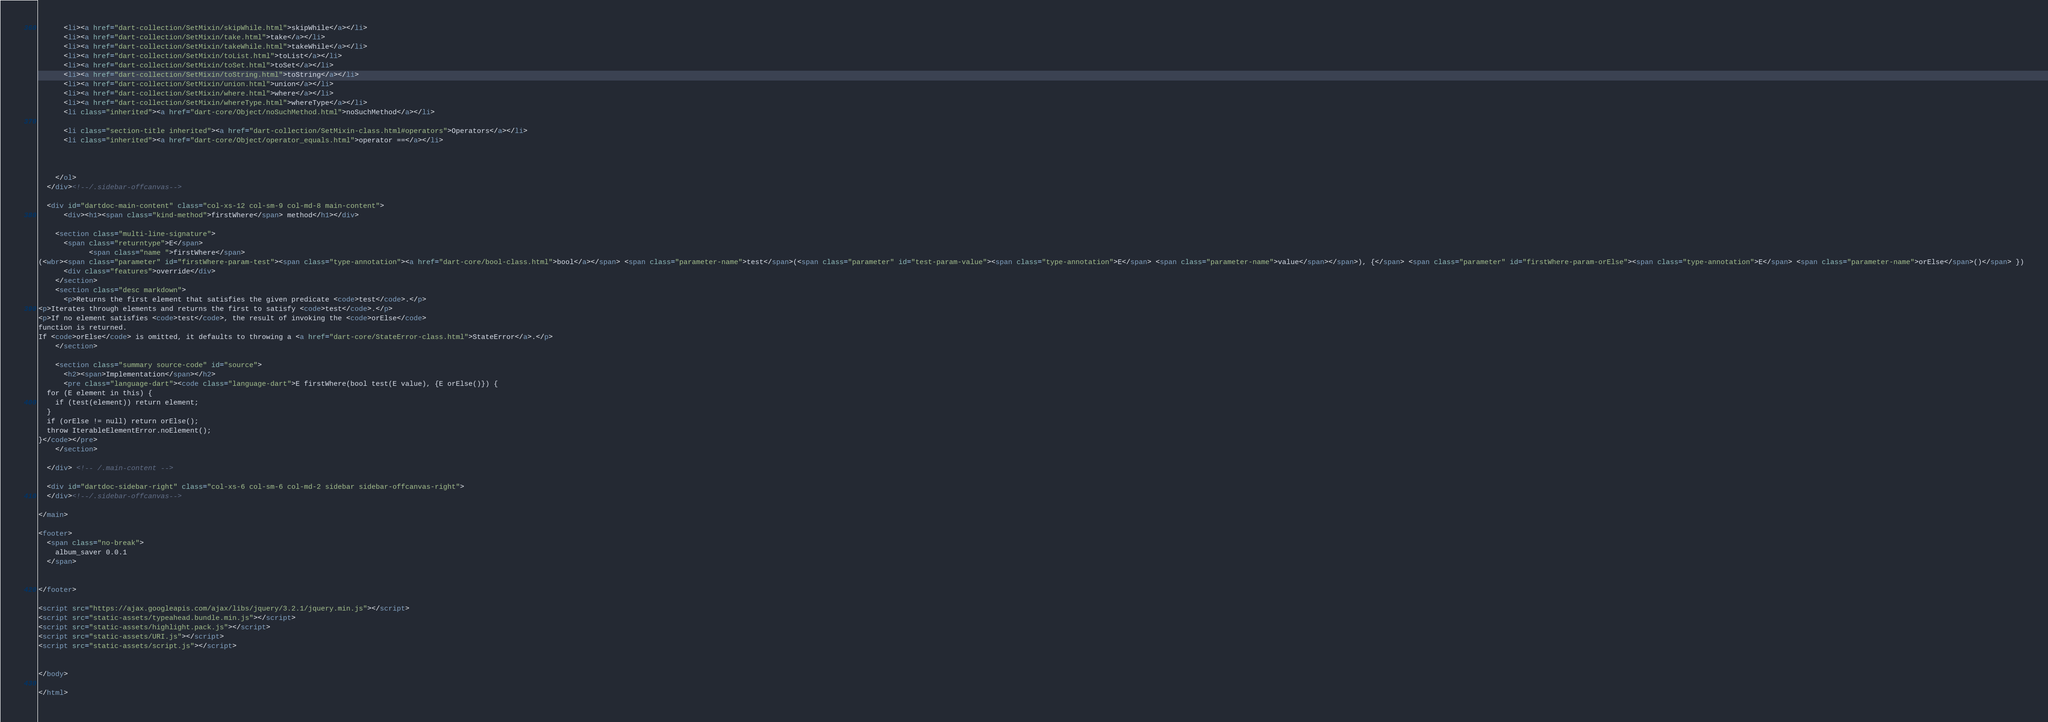Convert code to text. <code><loc_0><loc_0><loc_500><loc_500><_HTML_>      <li><a href="dart-collection/SetMixin/skipWhile.html">skipWhile</a></li>
      <li><a href="dart-collection/SetMixin/take.html">take</a></li>
      <li><a href="dart-collection/SetMixin/takeWhile.html">takeWhile</a></li>
      <li><a href="dart-collection/SetMixin/toList.html">toList</a></li>
      <li><a href="dart-collection/SetMixin/toSet.html">toSet</a></li>
      <li><a href="dart-collection/SetMixin/toString.html">toString</a></li>
      <li><a href="dart-collection/SetMixin/union.html">union</a></li>
      <li><a href="dart-collection/SetMixin/where.html">where</a></li>
      <li><a href="dart-collection/SetMixin/whereType.html">whereType</a></li>
      <li class="inherited"><a href="dart-core/Object/noSuchMethod.html">noSuchMethod</a></li>
    
      <li class="section-title inherited"><a href="dart-collection/SetMixin-class.html#operators">Operators</a></li>
      <li class="inherited"><a href="dart-core/Object/operator_equals.html">operator ==</a></li>
    
    
    
    </ol>
  </div><!--/.sidebar-offcanvas-->

  <div id="dartdoc-main-content" class="col-xs-12 col-sm-9 col-md-8 main-content">
      <div><h1><span class="kind-method">firstWhere</span> method</h1></div>

    <section class="multi-line-signature">
      <span class="returntype">E</span>
            <span class="name ">firstWhere</span>
(<wbr><span class="parameter" id="firstWhere-param-test"><span class="type-annotation"><a href="dart-core/bool-class.html">bool</a></span> <span class="parameter-name">test</span>(<span class="parameter" id="test-param-value"><span class="type-annotation">E</span> <span class="parameter-name">value</span></span>), {</span> <span class="parameter" id="firstWhere-param-orElse"><span class="type-annotation">E</span> <span class="parameter-name">orElse</span>()</span> })
      <div class="features">override</div>
    </section>
    <section class="desc markdown">
      <p>Returns the first element that satisfies the given predicate <code>test</code>.</p>
<p>Iterates through elements and returns the first to satisfy <code>test</code>.</p>
<p>If no element satisfies <code>test</code>, the result of invoking the <code>orElse</code>
function is returned.
If <code>orElse</code> is omitted, it defaults to throwing a <a href="dart-core/StateError-class.html">StateError</a>.</p>
    </section>
    
    <section class="summary source-code" id="source">
      <h2><span>Implementation</span></h2>
      <pre class="language-dart"><code class="language-dart">E firstWhere(bool test(E value), {E orElse()}) {
  for (E element in this) {
    if (test(element)) return element;
  }
  if (orElse != null) return orElse();
  throw IterableElementError.noElement();
}</code></pre>
    </section>

  </div> <!-- /.main-content -->

  <div id="dartdoc-sidebar-right" class="col-xs-6 col-sm-6 col-md-2 sidebar sidebar-offcanvas-right">
  </div><!--/.sidebar-offcanvas-->

</main>

<footer>
  <span class="no-break">
    album_saver 0.0.1
  </span>

  
</footer>

<script src="https://ajax.googleapis.com/ajax/libs/jquery/3.2.1/jquery.min.js"></script>
<script src="static-assets/typeahead.bundle.min.js"></script>
<script src="static-assets/highlight.pack.js"></script>
<script src="static-assets/URI.js"></script>
<script src="static-assets/script.js"></script>


</body>

</html>
</code> 